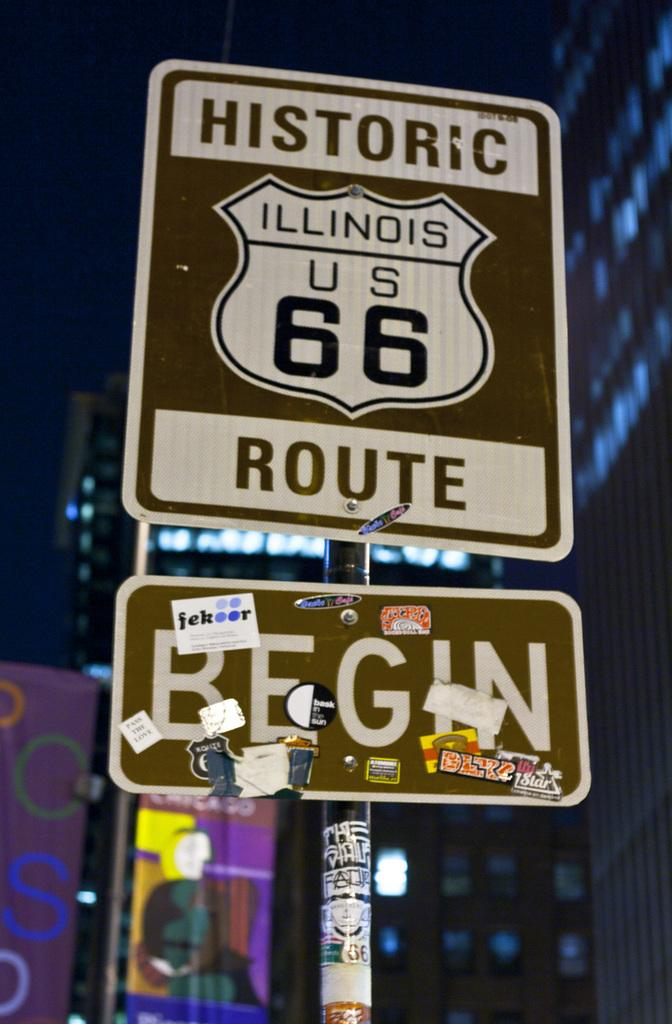Provide a one-sentence caption for the provided image. Sign on the road that says Historic route Begin. 